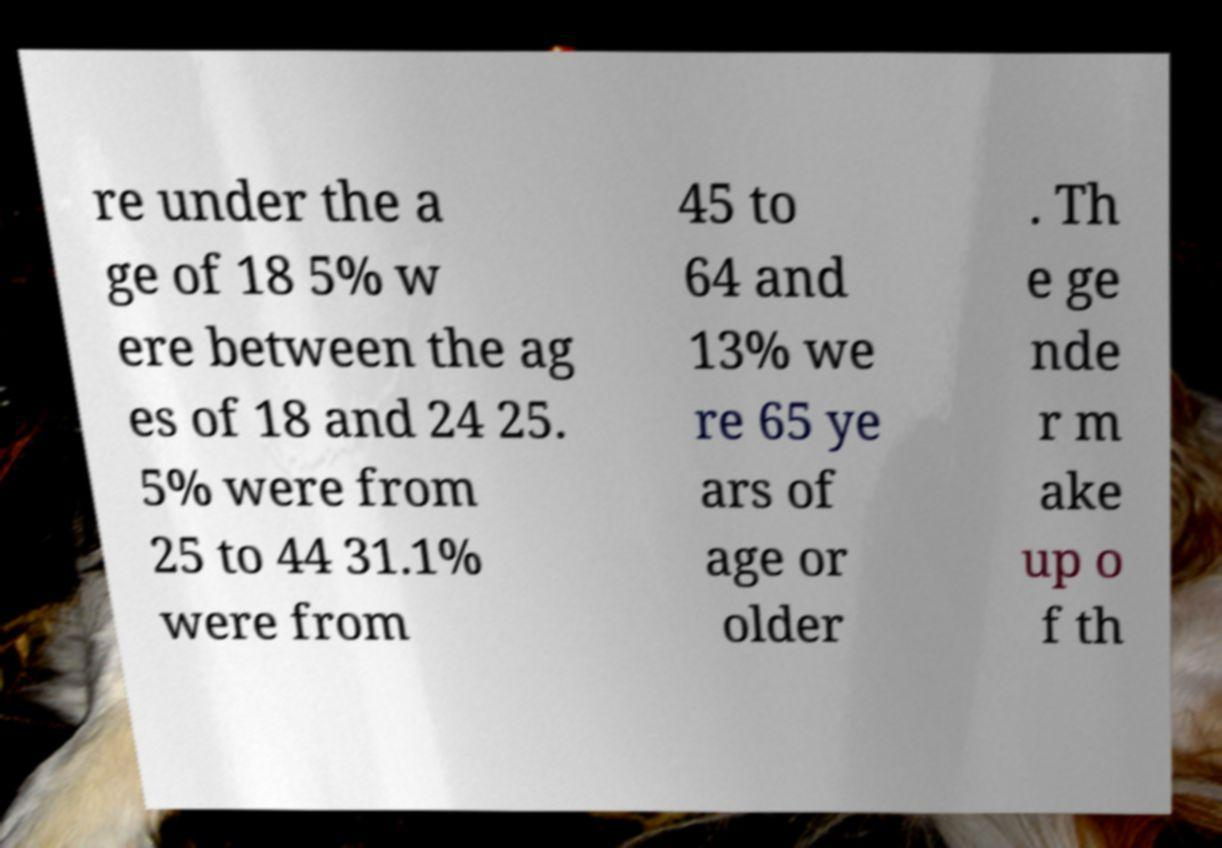Can you accurately transcribe the text from the provided image for me? re under the a ge of 18 5% w ere between the ag es of 18 and 24 25. 5% were from 25 to 44 31.1% were from 45 to 64 and 13% we re 65 ye ars of age or older . Th e ge nde r m ake up o f th 